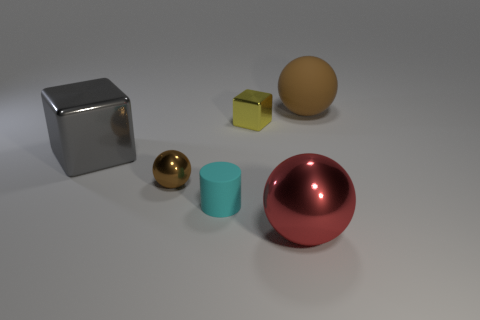Subtract all gray blocks. Subtract all yellow balls. How many blocks are left? 1 Add 2 big cyan rubber cylinders. How many objects exist? 8 Subtract all blocks. How many objects are left? 4 Add 3 brown matte objects. How many brown matte objects are left? 4 Add 5 yellow things. How many yellow things exist? 6 Subtract 0 gray cylinders. How many objects are left? 6 Subtract all tiny brown spheres. Subtract all big brown rubber objects. How many objects are left? 4 